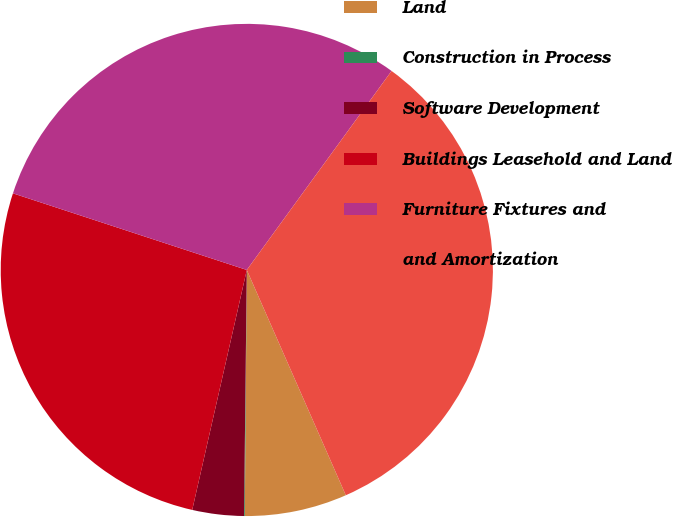Convert chart to OTSL. <chart><loc_0><loc_0><loc_500><loc_500><pie_chart><fcel>Land<fcel>Construction in Process<fcel>Software Development<fcel>Buildings Leasehold and Land<fcel>Furniture Fixtures and<fcel>and Amortization<nl><fcel>6.72%<fcel>0.05%<fcel>3.38%<fcel>26.48%<fcel>29.97%<fcel>33.4%<nl></chart> 